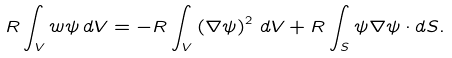<formula> <loc_0><loc_0><loc_500><loc_500>R \int _ { V } w \psi \, d V = - R \int _ { V } \left ( \nabla \psi \right ) ^ { 2 } \, d V + R \int _ { S } \psi \nabla \psi \cdot { d S } .</formula> 